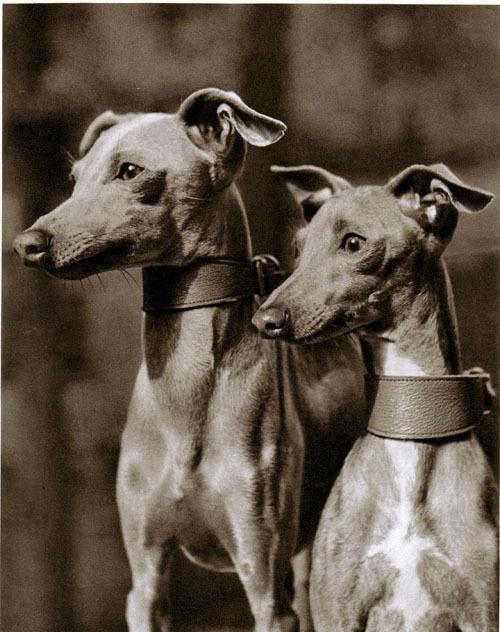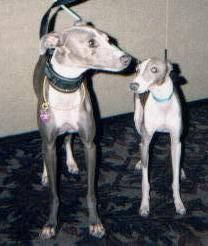The first image is the image on the left, the second image is the image on the right. For the images shown, is this caption "there are only two canines in the image on the right side" true? Answer yes or no. Yes. The first image is the image on the left, the second image is the image on the right. For the images displayed, is the sentence "One image contains five dogs." factually correct? Answer yes or no. No. 